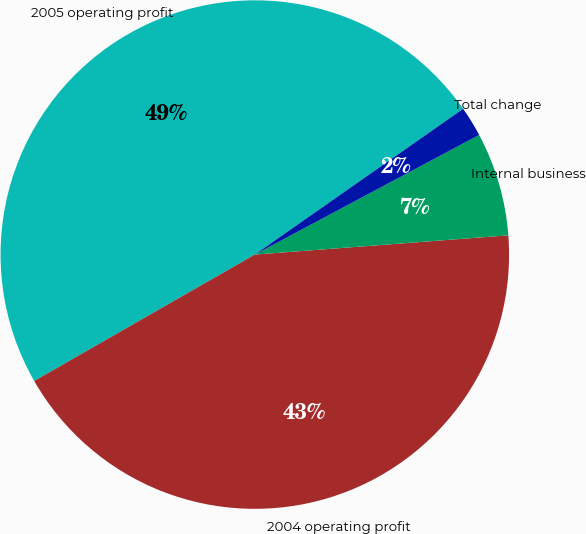<chart> <loc_0><loc_0><loc_500><loc_500><pie_chart><fcel>2005 operating profit<fcel>2004 operating profit<fcel>Internal business<fcel>Total change<nl><fcel>48.56%<fcel>42.92%<fcel>6.59%<fcel>1.92%<nl></chart> 